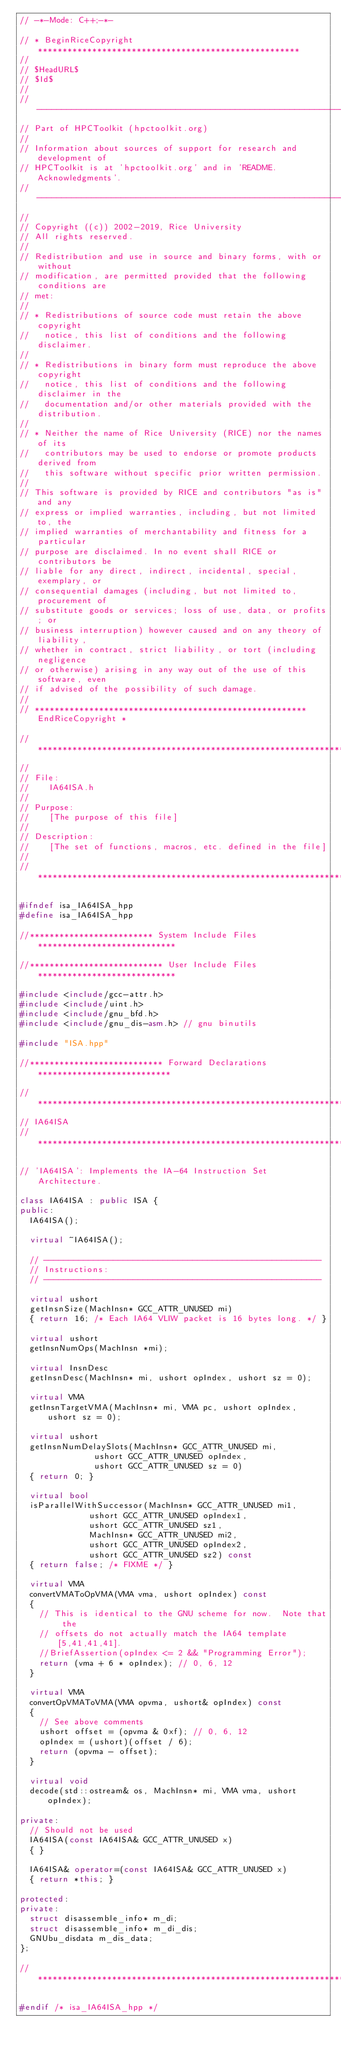Convert code to text. <code><loc_0><loc_0><loc_500><loc_500><_C++_>// -*-Mode: C++;-*-

// * BeginRiceCopyright *****************************************************
//
// $HeadURL$
// $Id$
//
// --------------------------------------------------------------------------
// Part of HPCToolkit (hpctoolkit.org)
//
// Information about sources of support for research and development of
// HPCToolkit is at 'hpctoolkit.org' and in 'README.Acknowledgments'.
// --------------------------------------------------------------------------
//
// Copyright ((c)) 2002-2019, Rice University
// All rights reserved.
//
// Redistribution and use in source and binary forms, with or without
// modification, are permitted provided that the following conditions are
// met:
//
// * Redistributions of source code must retain the above copyright
//   notice, this list of conditions and the following disclaimer.
//
// * Redistributions in binary form must reproduce the above copyright
//   notice, this list of conditions and the following disclaimer in the
//   documentation and/or other materials provided with the distribution.
//
// * Neither the name of Rice University (RICE) nor the names of its
//   contributors may be used to endorse or promote products derived from
//   this software without specific prior written permission.
//
// This software is provided by RICE and contributors "as is" and any
// express or implied warranties, including, but not limited to, the
// implied warranties of merchantability and fitness for a particular
// purpose are disclaimed. In no event shall RICE or contributors be
// liable for any direct, indirect, incidental, special, exemplary, or
// consequential damages (including, but not limited to, procurement of
// substitute goods or services; loss of use, data, or profits; or
// business interruption) however caused and on any theory of liability,
// whether in contract, strict liability, or tort (including negligence
// or otherwise) arising in any way out of the use of this software, even
// if advised of the possibility of such damage.
//
// ******************************************************* EndRiceCopyright *

//***************************************************************************
//
// File:
//    IA64ISA.h
//
// Purpose:
//    [The purpose of this file]
//
// Description:
//    [The set of functions, macros, etc. defined in the file]
//
//***************************************************************************

#ifndef isa_IA64ISA_hpp
#define isa_IA64ISA_hpp

//************************* System Include Files ****************************

//*************************** User Include Files ****************************

#include <include/gcc-attr.h>
#include <include/uint.h>
#include <include/gnu_bfd.h>
#include <include/gnu_dis-asm.h> // gnu binutils

#include "ISA.hpp"

//*************************** Forward Declarations ***************************

//***************************************************************************
// IA64ISA
//***************************************************************************

// 'IA64ISA': Implements the IA-64 Instruction Set Architecture.

class IA64ISA : public ISA {
public:
  IA64ISA();

  virtual ~IA64ISA();

  // --------------------------------------------------------
  // Instructions:
  // --------------------------------------------------------

  virtual ushort
  getInsnSize(MachInsn* GCC_ATTR_UNUSED mi)
  { return 16; /* Each IA64 VLIW packet is 16 bytes long. */ }

  virtual ushort
  getInsnNumOps(MachInsn *mi);

  virtual InsnDesc
  getInsnDesc(MachInsn* mi, ushort opIndex, ushort sz = 0);

  virtual VMA
  getInsnTargetVMA(MachInsn* mi, VMA pc, ushort opIndex, ushort sz = 0);

  virtual ushort
  getInsnNumDelaySlots(MachInsn* GCC_ATTR_UNUSED mi,
		       ushort GCC_ATTR_UNUSED opIndex,
		       ushort GCC_ATTR_UNUSED sz = 0)
  { return 0; }

  virtual bool
  isParallelWithSuccessor(MachInsn* GCC_ATTR_UNUSED mi1,
			  ushort GCC_ATTR_UNUSED opIndex1,
			  ushort GCC_ATTR_UNUSED sz1,
			  MachInsn* GCC_ATTR_UNUSED mi2,
			  ushort GCC_ATTR_UNUSED opIndex2,
			  ushort GCC_ATTR_UNUSED sz2) const
  { return false; /* FIXME */ }

  virtual VMA
  convertVMAToOpVMA(VMA vma, ushort opIndex) const
  {
    // This is identical to the GNU scheme for now.  Note that the
    // offsets do not actually match the IA64 template [5,41,41,41].
    //BriefAssertion(opIndex <= 2 && "Programming Error");
    return (vma + 6 * opIndex); // 0, 6, 12
  }

  virtual VMA
  convertOpVMAToVMA(VMA opvma, ushort& opIndex) const
  {
    // See above comments
    ushort offset = (opvma & 0xf); // 0, 6, 12
    opIndex = (ushort)(offset / 6);
    return (opvma - offset);
  }

  virtual void
  decode(std::ostream& os, MachInsn* mi, VMA vma, ushort opIndex);

private:
  // Should not be used
  IA64ISA(const IA64ISA& GCC_ATTR_UNUSED x)
  { }
  
  IA64ISA& operator=(const IA64ISA& GCC_ATTR_UNUSED x)
  { return *this; }

protected:
private:
  struct disassemble_info* m_di;
  struct disassemble_info* m_di_dis;
  GNUbu_disdata m_dis_data;
};

//****************************************************************************

#endif /* isa_IA64ISA_hpp */
</code> 